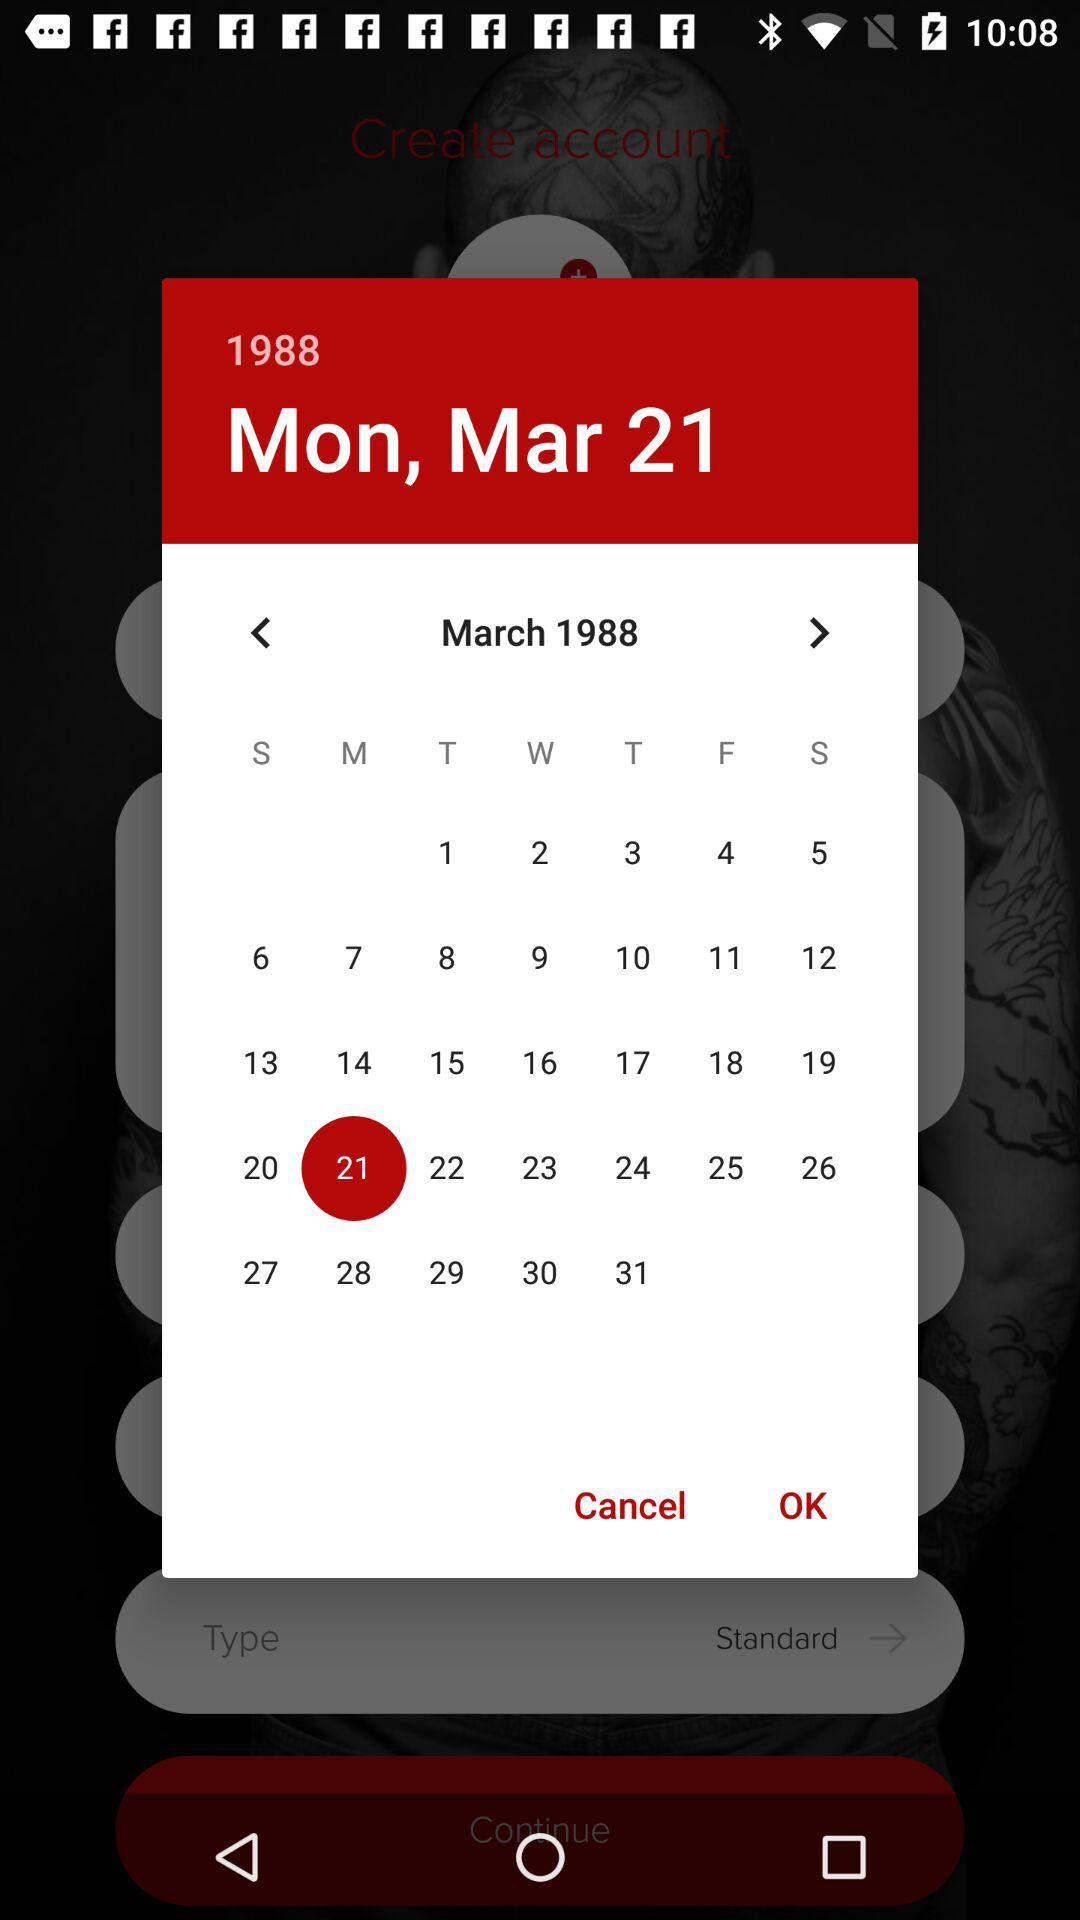What day falls on March 9th, 1988? The day is Wednesday. 